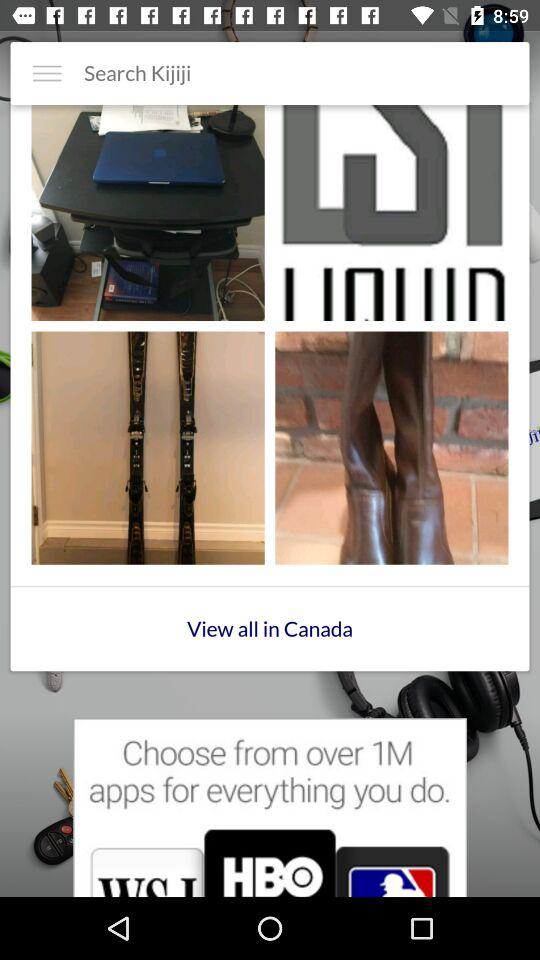How many apps are there to choose from "for everything you do"? There are over 1 million apps. 